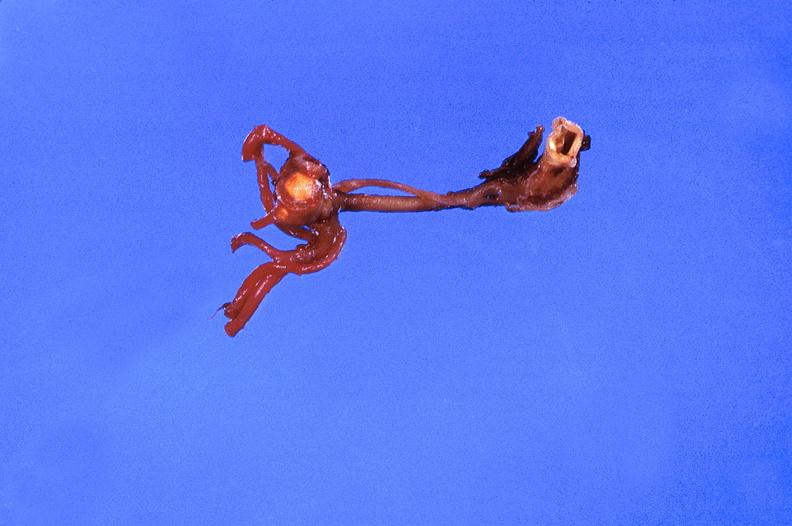s cardiovascular present?
Answer the question using a single word or phrase. Yes 